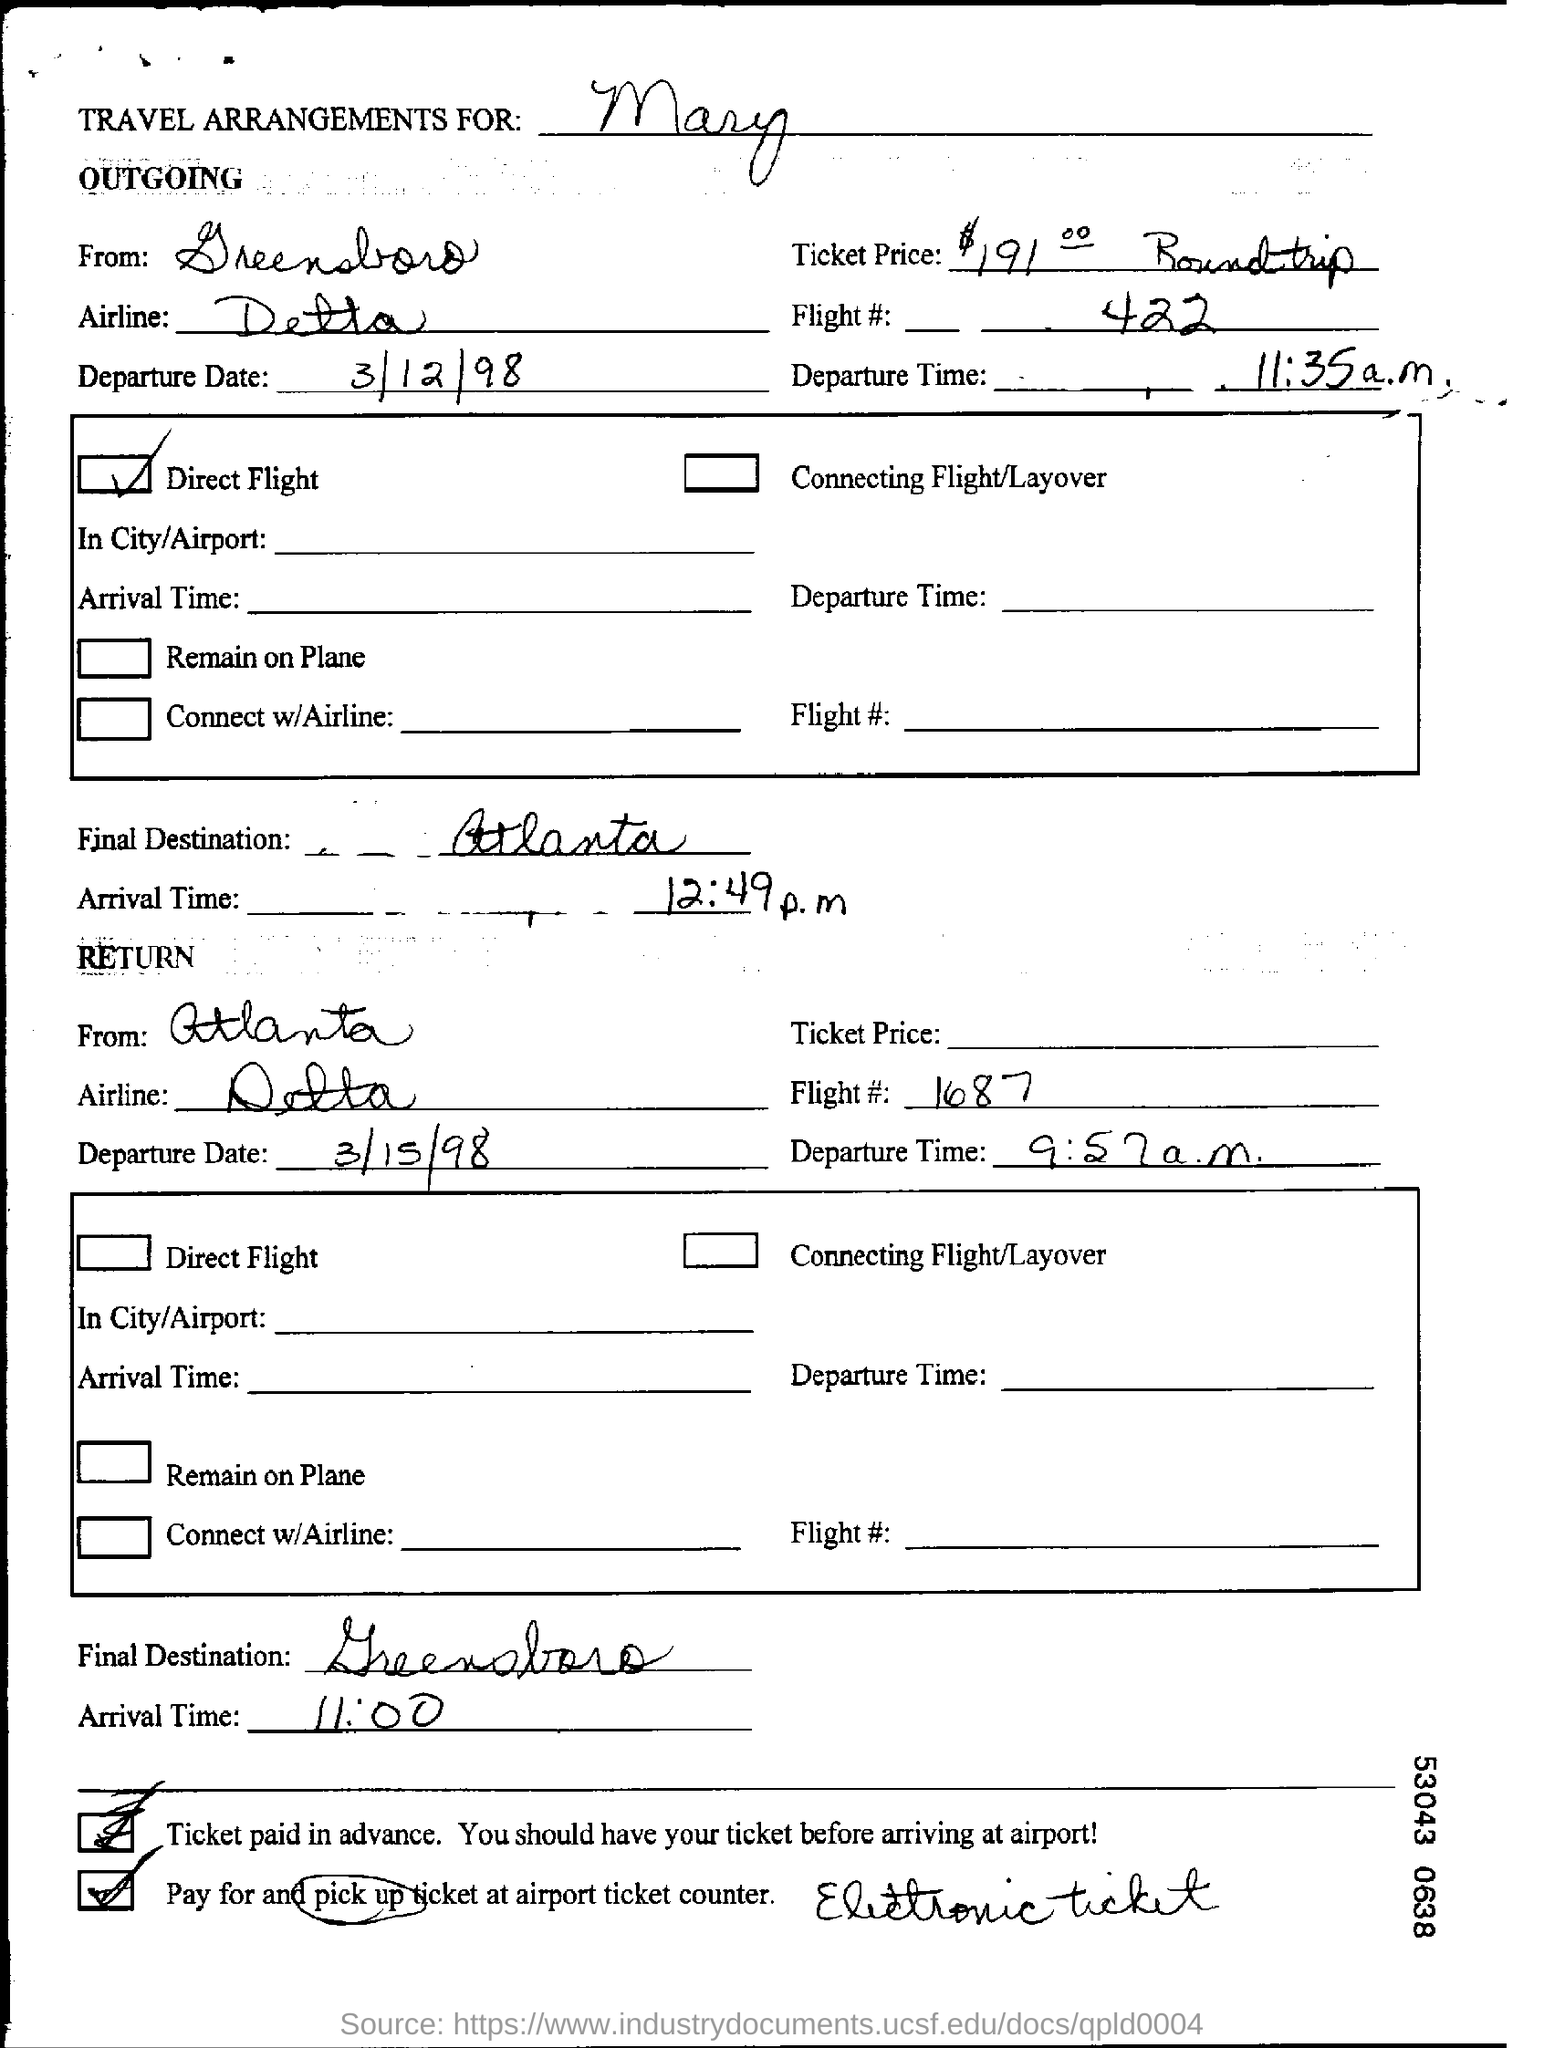Outline some significant characteristics in this image. Outgoing is the direct flight. The flight number in the return journey is 1687. The return flight's expected arrival time is 11:00. The travel arrangements are made for Mary. The final destination of the outgoing journey is Atlanta. 